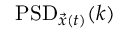<formula> <loc_0><loc_0><loc_500><loc_500>P S D _ { \vec { x } ( t ) } ( k )</formula> 